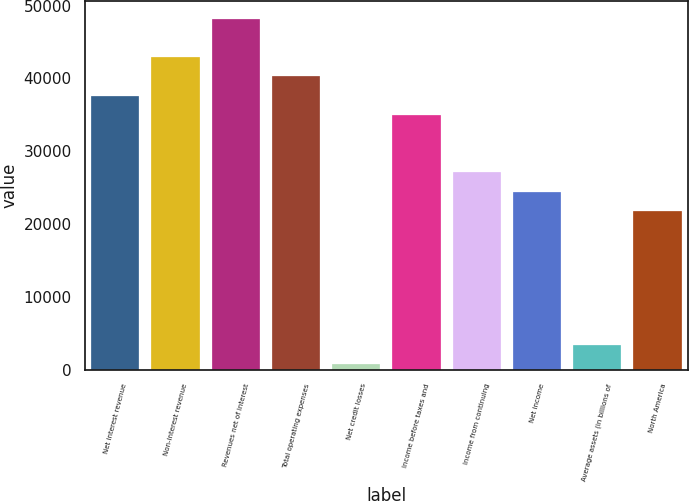Convert chart. <chart><loc_0><loc_0><loc_500><loc_500><bar_chart><fcel>Net interest revenue<fcel>Non-interest revenue<fcel>Revenues net of interest<fcel>Total operating expenses<fcel>Net credit losses<fcel>Income before taxes and<fcel>Income from continuing<fcel>Net income<fcel>Average assets (in billions of<fcel>North America<nl><fcel>37655.8<fcel>42929.2<fcel>48202.6<fcel>40292.5<fcel>742<fcel>35019.1<fcel>27109<fcel>24472.3<fcel>3378.7<fcel>21835.6<nl></chart> 